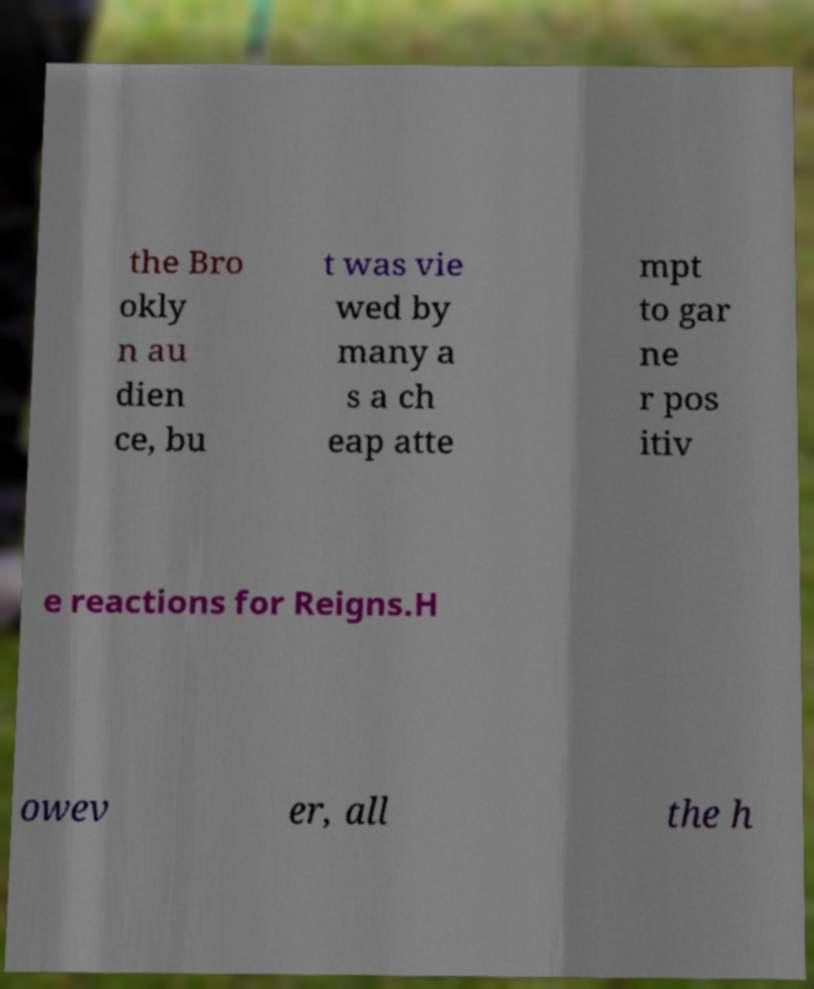Please read and relay the text visible in this image. What does it say? the Bro okly n au dien ce, bu t was vie wed by many a s a ch eap atte mpt to gar ne r pos itiv e reactions for Reigns.H owev er, all the h 